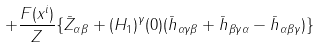<formula> <loc_0><loc_0><loc_500><loc_500>+ \frac { F ( x ^ { i } ) } { Z } \{ \bar { Z } _ { \alpha \beta } + ( H _ { 1 } ) ^ { \gamma } ( 0 ) ( \bar { h } _ { \alpha \gamma \beta } + \bar { h } _ { \beta \gamma \alpha } - \bar { h } _ { \alpha \beta \gamma } ) \}</formula> 